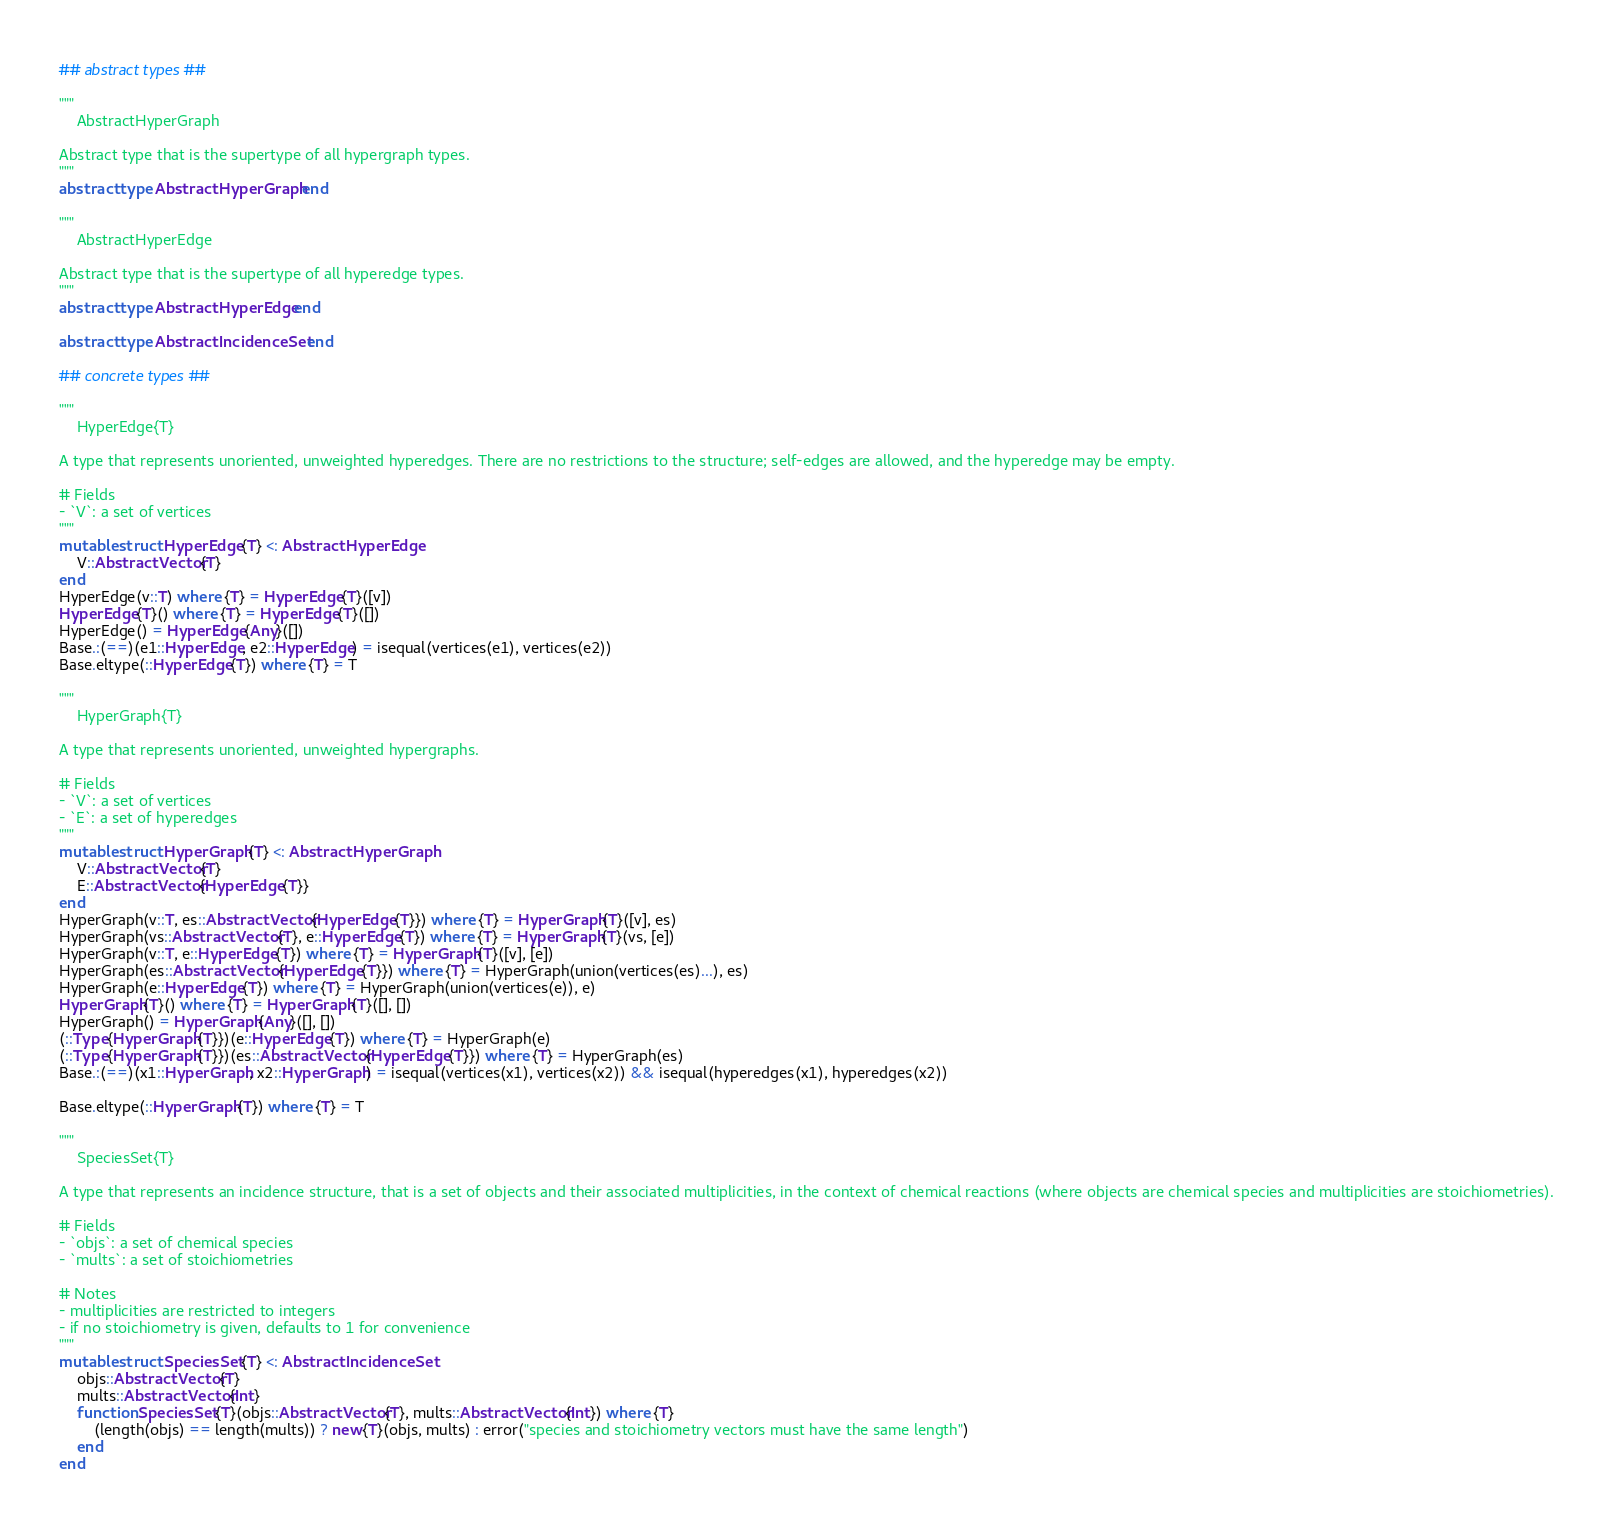Convert code to text. <code><loc_0><loc_0><loc_500><loc_500><_Julia_>## abstract types ##

"""
    AbstractHyperGraph

Abstract type that is the supertype of all hypergraph types.
"""
abstract type AbstractHyperGraph end

"""
    AbstractHyperEdge

Abstract type that is the supertype of all hyperedge types.
"""
abstract type AbstractHyperEdge end

abstract type AbstractIncidenceSet end

## concrete types ##

"""
    HyperEdge{T}

A type that represents unoriented, unweighted hyperedges. There are no restrictions to the structure; self-edges are allowed, and the hyperedge may be empty.

# Fields
- `V`: a set of vertices
"""
mutable struct HyperEdge{T} <: AbstractHyperEdge
    V::AbstractVector{T}
end
HyperEdge(v::T) where {T} = HyperEdge{T}([v])
HyperEdge{T}() where {T} = HyperEdge{T}([])
HyperEdge() = HyperEdge{Any}([])
Base.:(==)(e1::HyperEdge, e2::HyperEdge) = isequal(vertices(e1), vertices(e2))
Base.eltype(::HyperEdge{T}) where {T} = T

"""
    HyperGraph{T}

A type that represents unoriented, unweighted hypergraphs.

# Fields
- `V`: a set of vertices
- `E`: a set of hyperedges
"""
mutable struct HyperGraph{T} <: AbstractHyperGraph
    V::AbstractVector{T}
    E::AbstractVector{HyperEdge{T}}
end
HyperGraph(v::T, es::AbstractVector{HyperEdge{T}}) where {T} = HyperGraph{T}([v], es)
HyperGraph(vs::AbstractVector{T}, e::HyperEdge{T}) where {T} = HyperGraph{T}(vs, [e])
HyperGraph(v::T, e::HyperEdge{T}) where {T} = HyperGraph{T}([v], [e])
HyperGraph(es::AbstractVector{HyperEdge{T}}) where {T} = HyperGraph(union(vertices(es)...), es)
HyperGraph(e::HyperEdge{T}) where {T} = HyperGraph(union(vertices(e)), e)
HyperGraph{T}() where {T} = HyperGraph{T}([], [])
HyperGraph() = HyperGraph{Any}([], [])
(::Type{HyperGraph{T}})(e::HyperEdge{T}) where {T} = HyperGraph(e)
(::Type{HyperGraph{T}})(es::AbstractVector{HyperEdge{T}}) where {T} = HyperGraph(es)
Base.:(==)(x1::HyperGraph, x2::HyperGraph) = isequal(vertices(x1), vertices(x2)) && isequal(hyperedges(x1), hyperedges(x2))

Base.eltype(::HyperGraph{T}) where {T} = T

"""
    SpeciesSet{T}

A type that represents an incidence structure, that is a set of objects and their associated multiplicities, in the context of chemical reactions (where objects are chemical species and multiplicities are stoichiometries).

# Fields
- `objs`: a set of chemical species
- `mults`: a set of stoichiometries

# Notes
- multiplicities are restricted to integers
- if no stoichiometry is given, defaults to 1 for convenience
"""
mutable struct SpeciesSet{T} <: AbstractIncidenceSet
    objs::AbstractVector{T}
    mults::AbstractVector{Int}
    function SpeciesSet{T}(objs::AbstractVector{T}, mults::AbstractVector{Int}) where {T}
        (length(objs) == length(mults)) ? new{T}(objs, mults) : error("species and stoichiometry vectors must have the same length")
    end
end</code> 